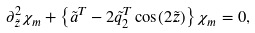<formula> <loc_0><loc_0><loc_500><loc_500>\partial _ { \tilde { z } } ^ { 2 } { \chi _ { m } } + \left \{ \tilde { a } ^ { T } - 2 \tilde { q } _ { 2 } ^ { T } \cos ( 2 \tilde { z } ) \right \} \chi _ { m } = 0 ,</formula> 